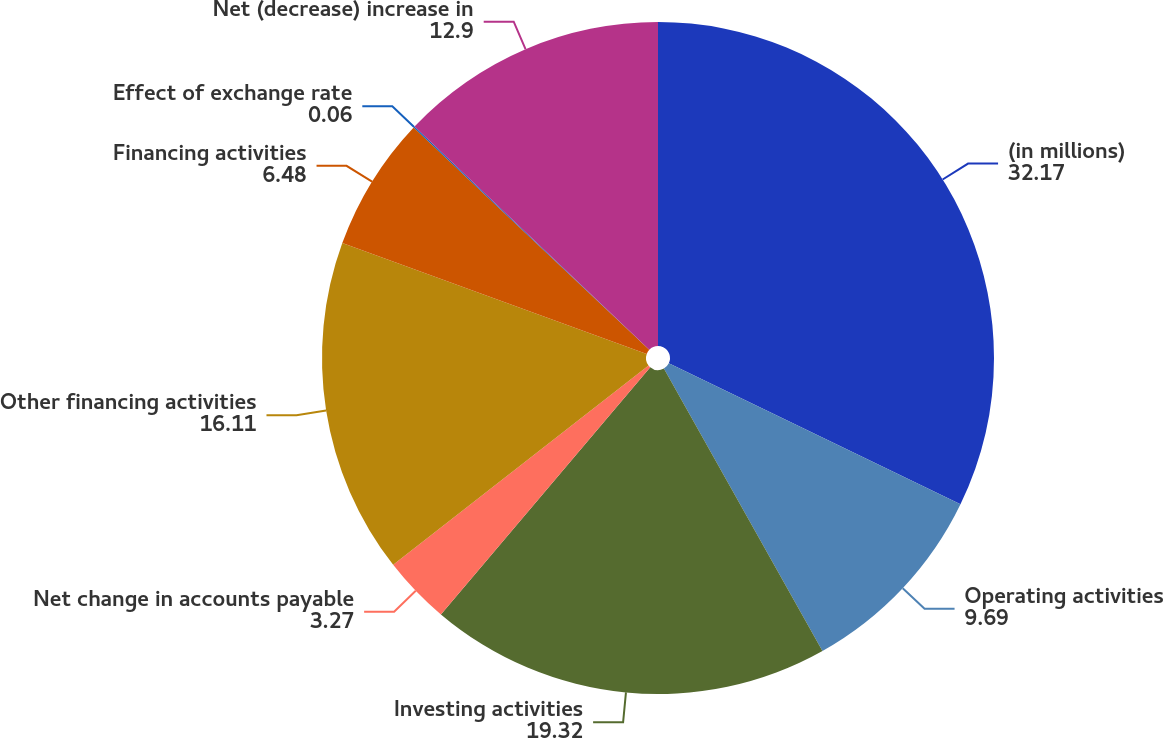<chart> <loc_0><loc_0><loc_500><loc_500><pie_chart><fcel>(in millions)<fcel>Operating activities<fcel>Investing activities<fcel>Net change in accounts payable<fcel>Other financing activities<fcel>Financing activities<fcel>Effect of exchange rate<fcel>Net (decrease) increase in<nl><fcel>32.17%<fcel>9.69%<fcel>19.32%<fcel>3.27%<fcel>16.11%<fcel>6.48%<fcel>0.06%<fcel>12.9%<nl></chart> 